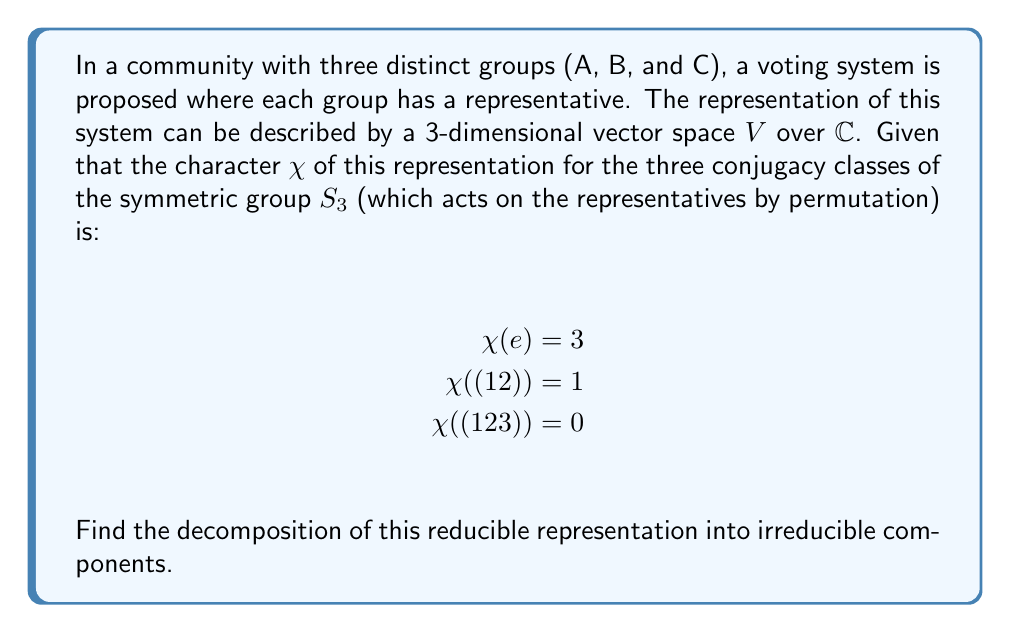Can you answer this question? To decompose this representation into irreducible components, we'll follow these steps:

1) Recall that $S_3$ has three irreducible representations: the trivial representation (1), the sign representation ($\epsilon$), and the standard representation ($\rho$).

2) The character table for $S_3$ is:

   $\begin{array}{c|ccc}
    & e & (12) & (123) \\
   \hline
   1 & 1 & 1 & 1 \\
   \epsilon & 1 & -1 & 1 \\
   \rho & 2 & 0 & -1
   \end{array}$

3) To find the multiplicity of each irreducible representation, we use the formula:

   $m_i = \frac{1}{|G|} \sum_{g \in G} \chi(g) \overline{\chi_i(g)}$

   where $|G| = 6$ for $S_3$, $\chi$ is our given character, and $\chi_i$ is the character of the irreducible representation.

4) For the trivial representation:
   $m_1 = \frac{1}{6}(3 \cdot 1 + 3 \cdot 1 + 2 \cdot 1) = 1$

5) For the sign representation:
   $m_\epsilon = \frac{1}{6}(3 \cdot 1 + 3 \cdot (-1) + 2 \cdot 1) = 0$

6) For the standard representation:
   $m_\rho = \frac{1}{6}(3 \cdot 2 + 3 \cdot 0 + 2 \cdot (-1)) = \frac{4}{6} = \frac{2}{3}$

7) The decomposition is therefore:

   $V \cong 1 \oplus \rho$

   This means the representation decomposes into one copy of the trivial representation and one copy of the standard representation.
Answer: $V \cong 1 \oplus \rho$ 